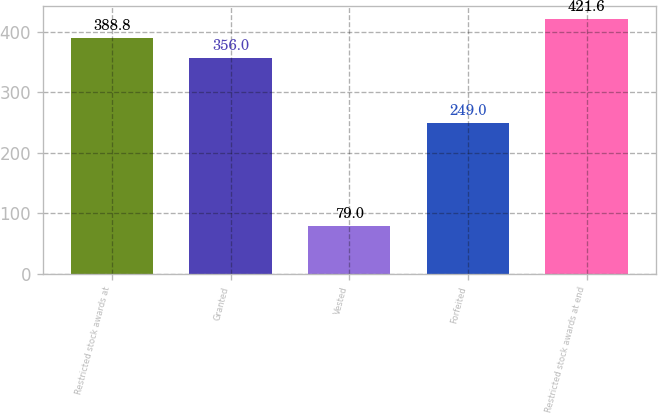Convert chart. <chart><loc_0><loc_0><loc_500><loc_500><bar_chart><fcel>Restricted stock awards at<fcel>Granted<fcel>Vested<fcel>Forfeited<fcel>Restricted stock awards at end<nl><fcel>388.8<fcel>356<fcel>79<fcel>249<fcel>421.6<nl></chart> 